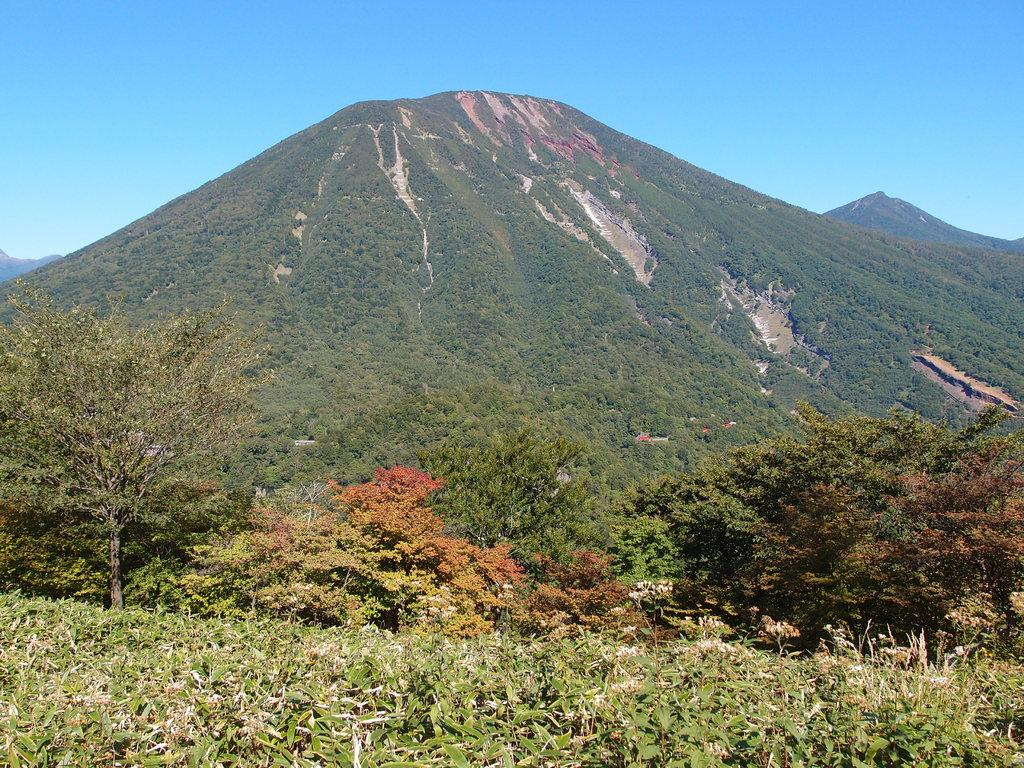What type of vegetation can be seen in the image? There are trees, plants, and grass visible in the image. What type of landscape is present at the bottom of the image? There is farmland at the bottom of the image. What can be seen in the background of the image? There are mountains in the background of the image. What is visible at the top of the image? The sky is visible at the top of the image. What type of drum is being played by the donkey in the image? There is no drum or donkey present in the image. 